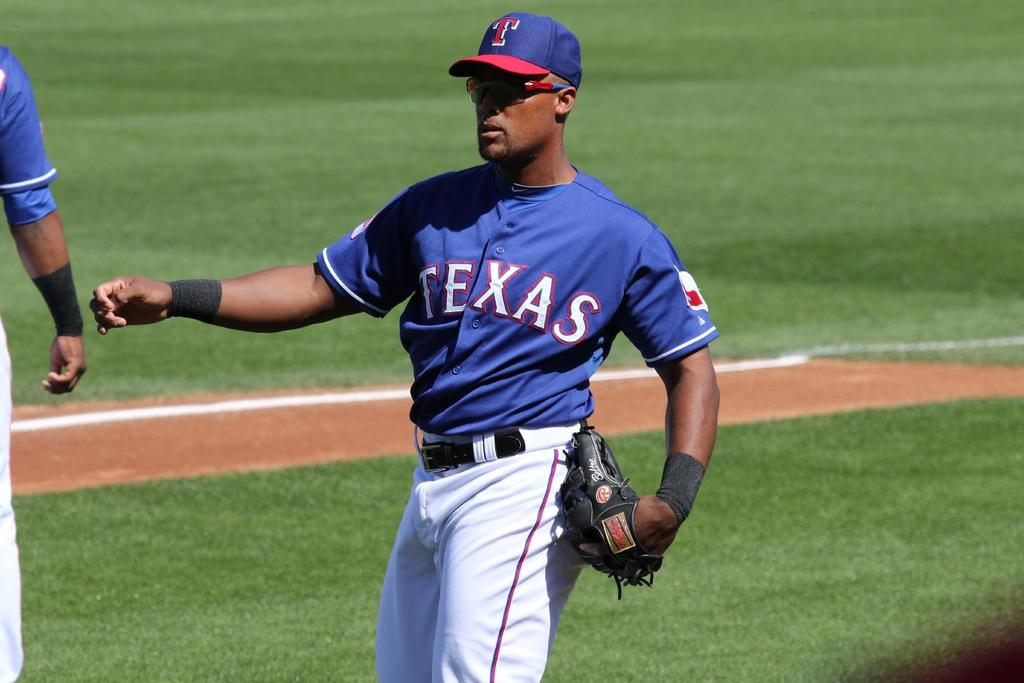<image>
Create a compact narrative representing the image presented. Baseball player wearing sunglasses and has TEXAS on the front of his uniform. 